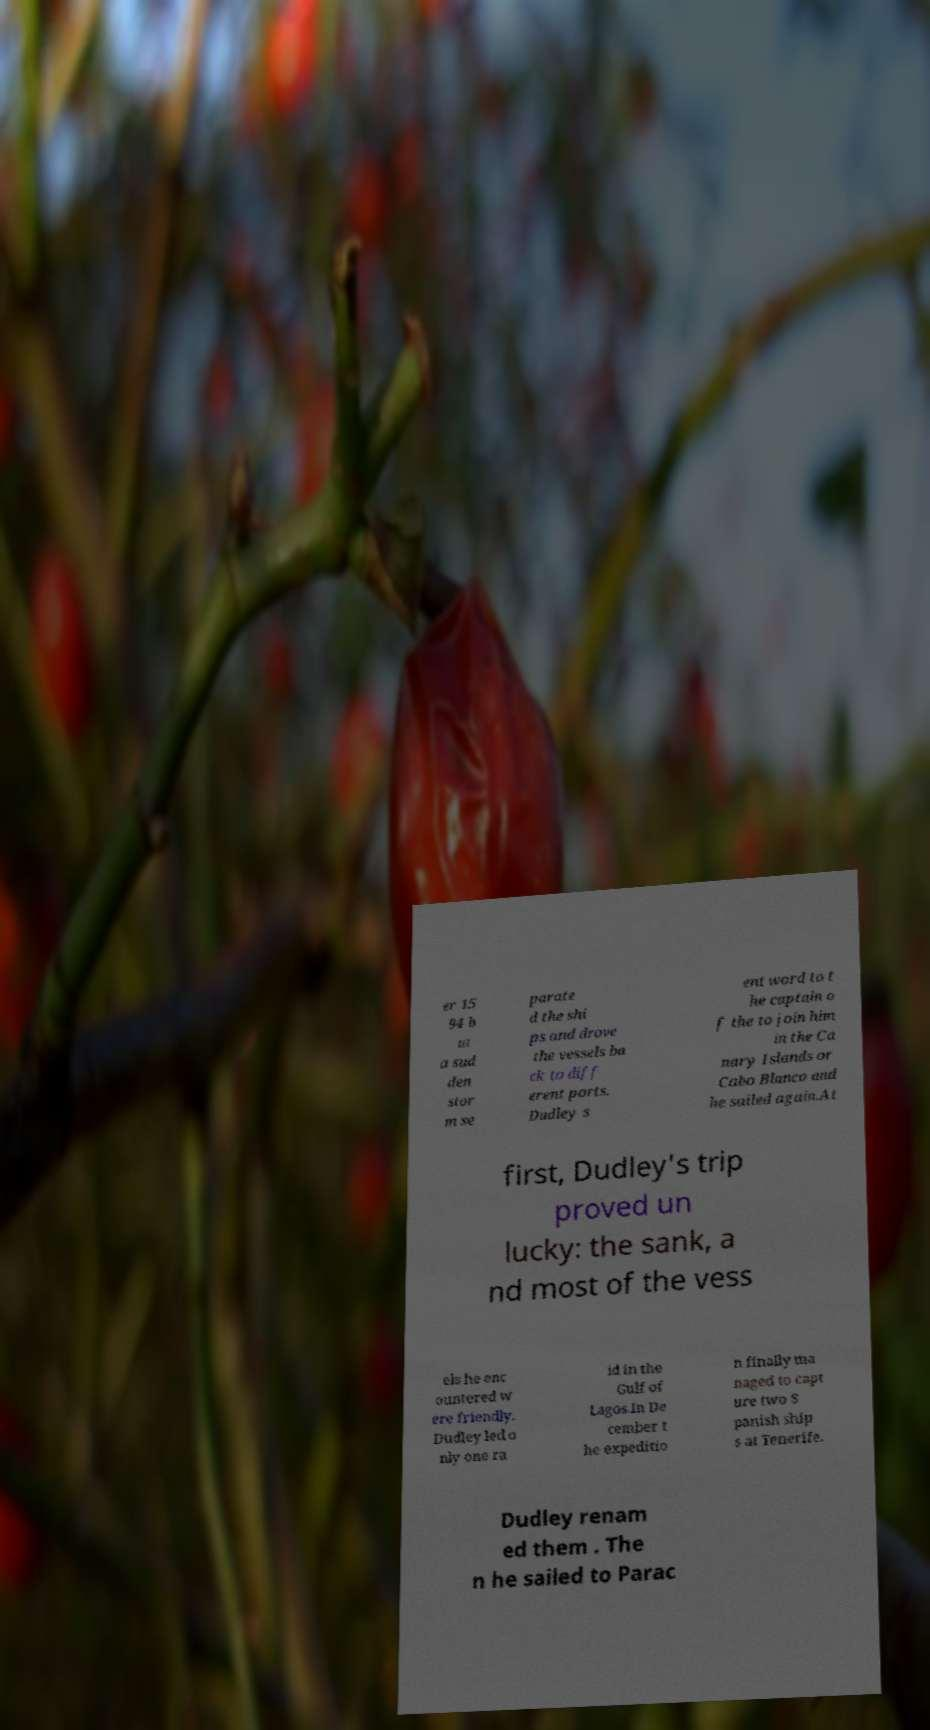Can you accurately transcribe the text from the provided image for me? er 15 94 b ut a sud den stor m se parate d the shi ps and drove the vessels ba ck to diff erent ports. Dudley s ent word to t he captain o f the to join him in the Ca nary Islands or Cabo Blanco and he sailed again.At first, Dudley's trip proved un lucky: the sank, a nd most of the vess els he enc ountered w ere friendly. Dudley led o nly one ra id in the Gulf of Lagos.In De cember t he expeditio n finally ma naged to capt ure two S panish ship s at Tenerife. Dudley renam ed them . The n he sailed to Parac 